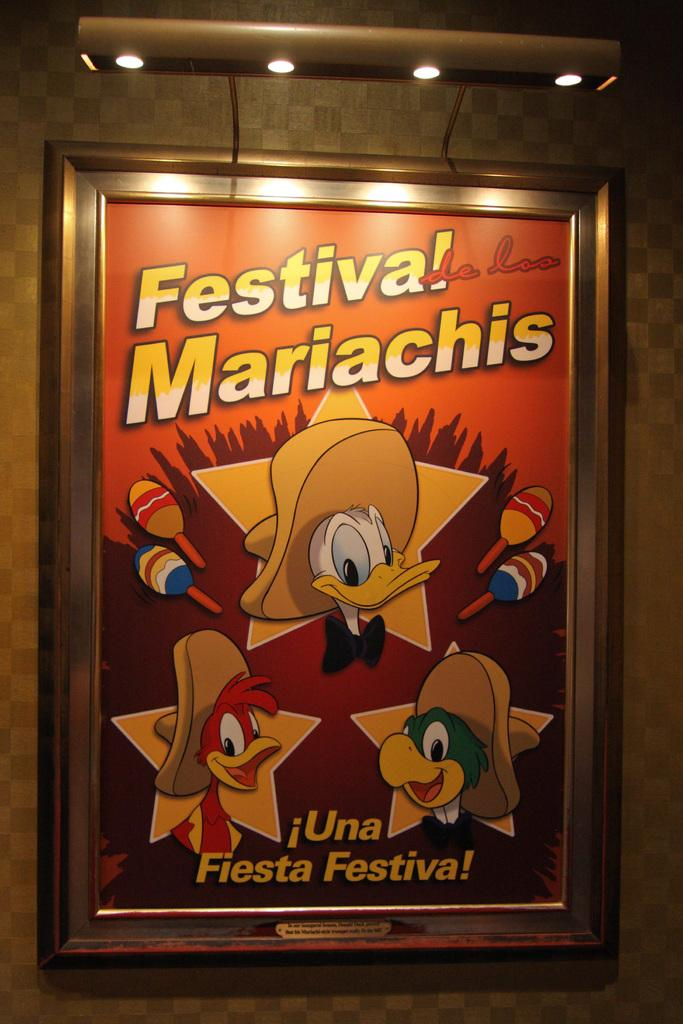What is the main subject of the image? The main subject of the image is a big frame with text and images. Where is the frame located in the image? The frame is attached to the wall. Are there any additional features on the frame? Yes, there are lights attached to the frame. What type of car can be seen participating in the protest in the image? There is no car or protest present in the image; it features a big frame with text and images attached to a wall with lights. What is the weight of the frame in the image? The weight of the frame cannot be determined from the image alone, as it does not provide information about the materials or dimensions of the frame. 